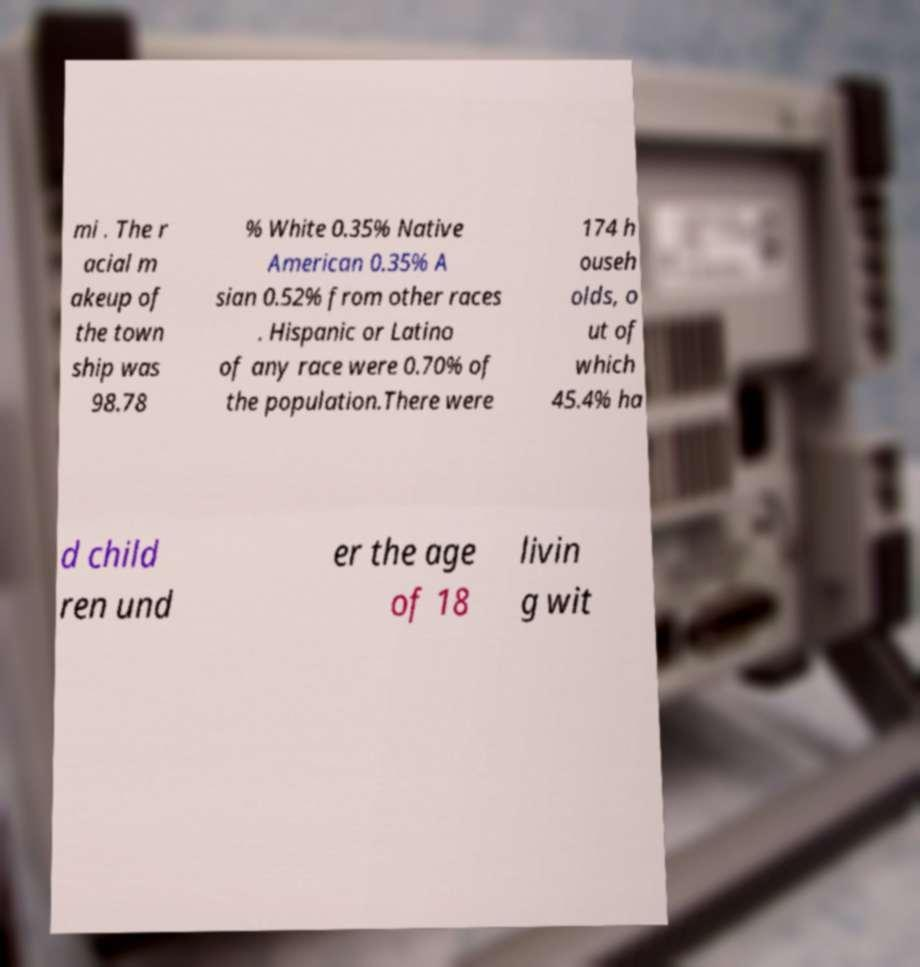For documentation purposes, I need the text within this image transcribed. Could you provide that? mi . The r acial m akeup of the town ship was 98.78 % White 0.35% Native American 0.35% A sian 0.52% from other races . Hispanic or Latino of any race were 0.70% of the population.There were 174 h ouseh olds, o ut of which 45.4% ha d child ren und er the age of 18 livin g wit 